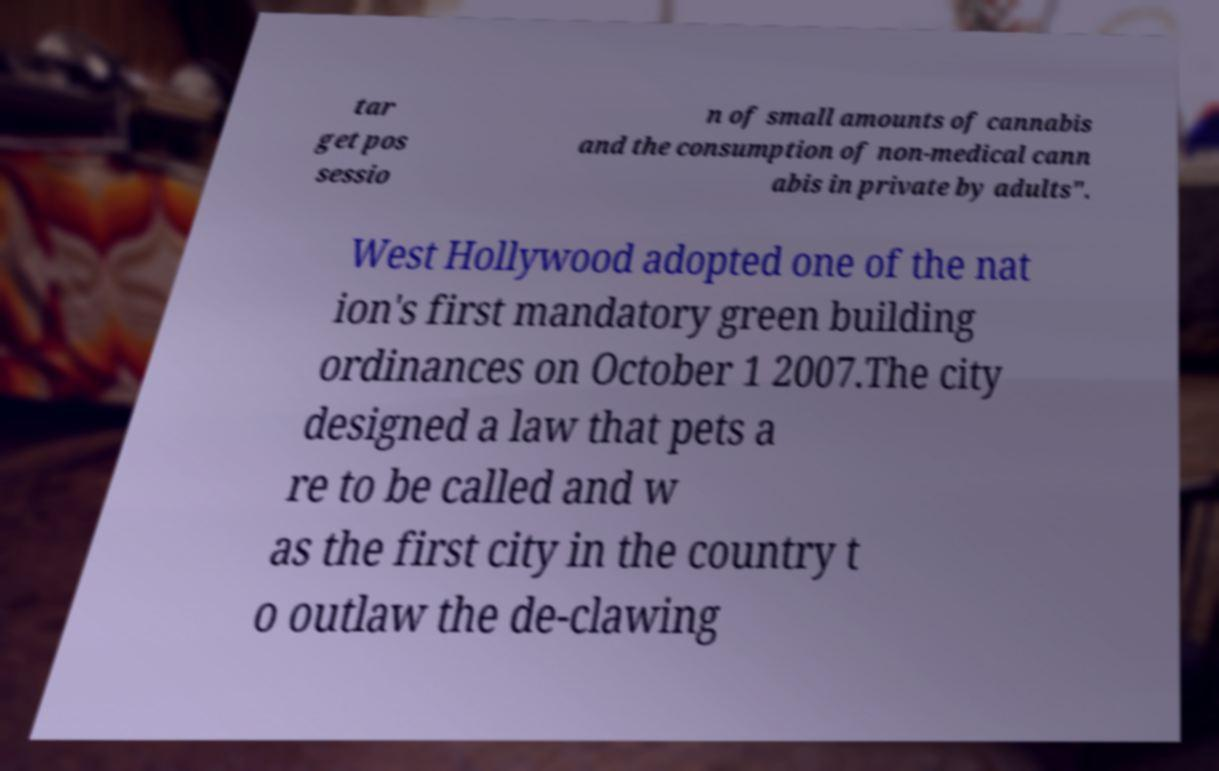Please read and relay the text visible in this image. What does it say? tar get pos sessio n of small amounts of cannabis and the consumption of non-medical cann abis in private by adults". West Hollywood adopted one of the nat ion's first mandatory green building ordinances on October 1 2007.The city designed a law that pets a re to be called and w as the first city in the country t o outlaw the de-clawing 